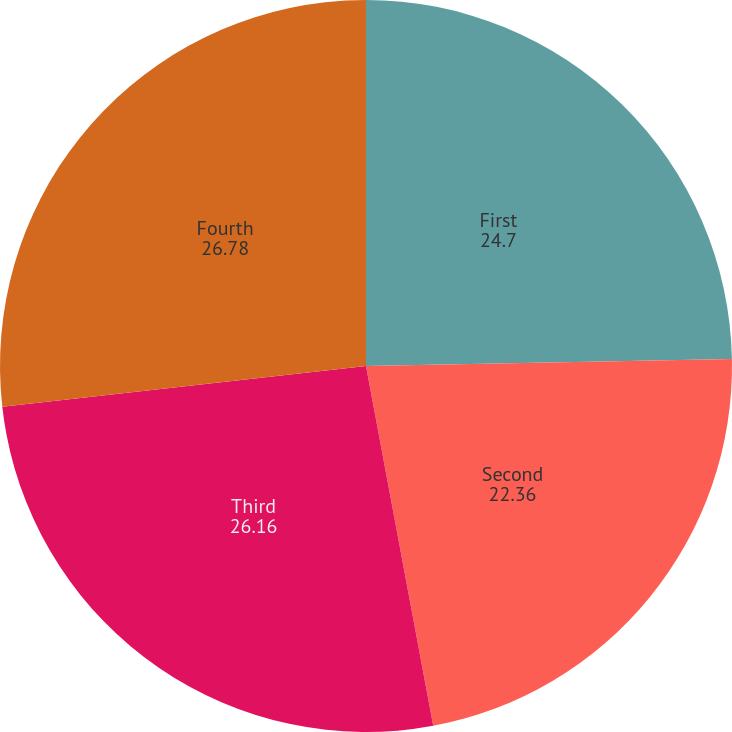<chart> <loc_0><loc_0><loc_500><loc_500><pie_chart><fcel>First<fcel>Second<fcel>Third<fcel>Fourth<nl><fcel>24.7%<fcel>22.36%<fcel>26.16%<fcel>26.78%<nl></chart> 